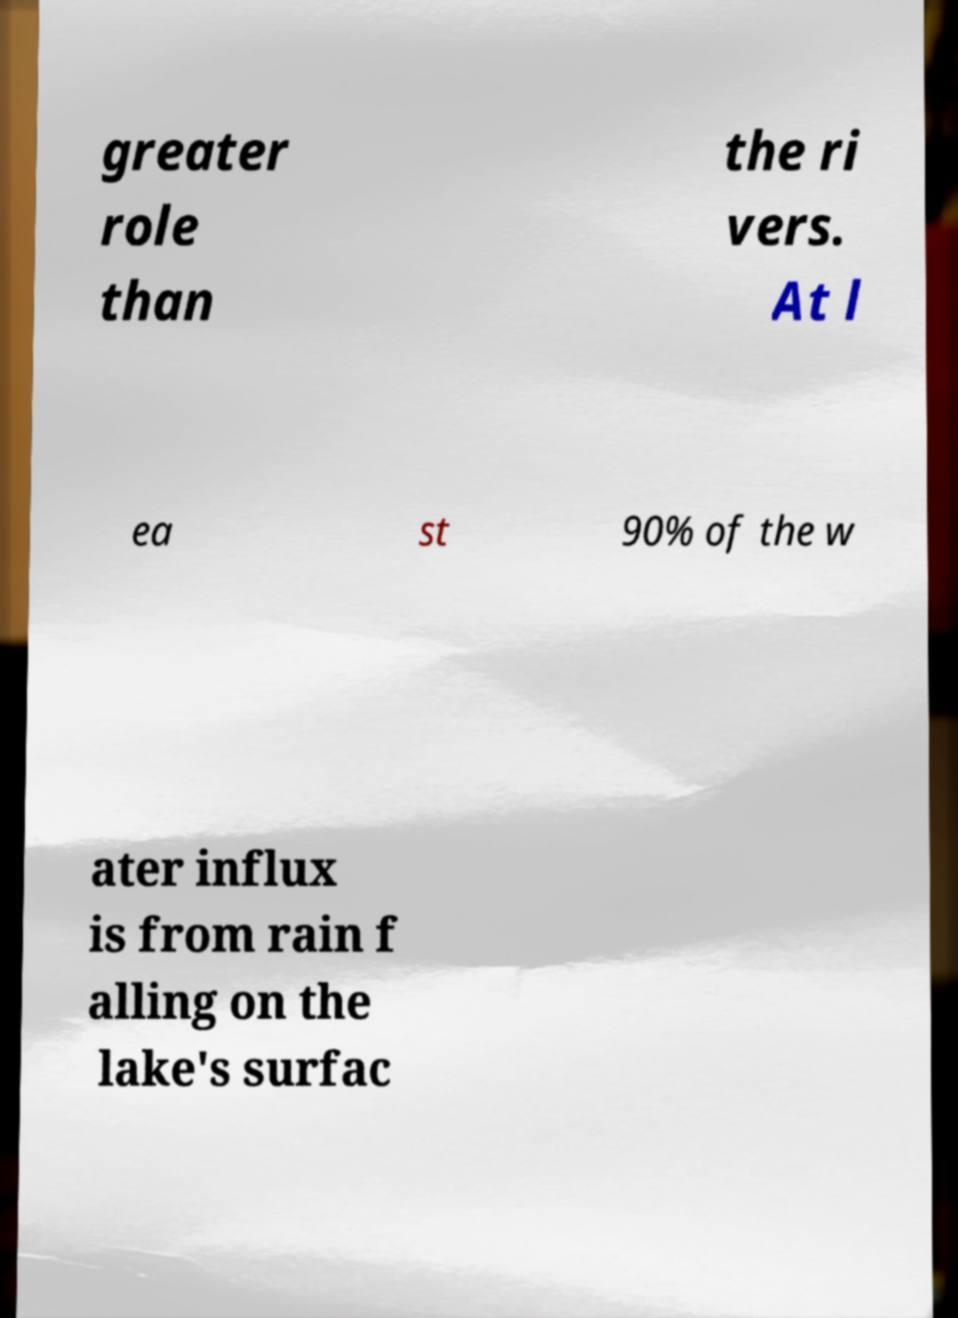There's text embedded in this image that I need extracted. Can you transcribe it verbatim? greater role than the ri vers. At l ea st 90% of the w ater influx is from rain f alling on the lake's surfac 